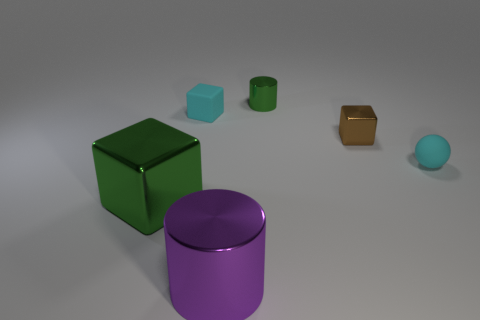Is there anything else of the same color as the big shiny cylinder?
Offer a terse response. No. How many balls are either tiny brown things or green things?
Offer a very short reply. 0. What number of green metal objects are both in front of the brown block and behind the green cube?
Your response must be concise. 0. Is the number of small cyan objects left of the brown metallic block the same as the number of large green shiny blocks that are in front of the big green cube?
Offer a very short reply. No. There is a tiny matte thing that is behind the tiny cyan sphere; is its shape the same as the big green thing?
Provide a succinct answer. Yes. The green thing that is on the right side of the thing in front of the green metal object that is left of the purple object is what shape?
Provide a short and direct response. Cylinder. There is a object that is the same color as the tiny rubber cube; what shape is it?
Offer a terse response. Sphere. The block that is left of the tiny brown shiny cube and in front of the tiny cyan rubber cube is made of what material?
Your response must be concise. Metal. Is the number of small rubber things less than the number of metal balls?
Ensure brevity in your answer.  No. There is a big purple shiny thing; does it have the same shape as the green thing on the right side of the large metal cube?
Keep it short and to the point. Yes. 